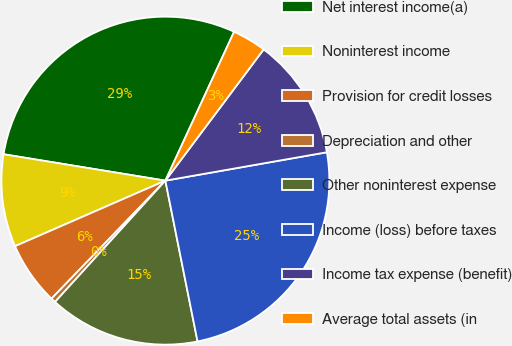Convert chart to OTSL. <chart><loc_0><loc_0><loc_500><loc_500><pie_chart><fcel>Net interest income(a)<fcel>Noninterest income<fcel>Provision for credit losses<fcel>Depreciation and other<fcel>Other noninterest expense<fcel>Income (loss) before taxes<fcel>Income tax expense (benefit)<fcel>Average total assets (in<nl><fcel>29.31%<fcel>9.12%<fcel>6.24%<fcel>0.47%<fcel>14.89%<fcel>24.63%<fcel>12.0%<fcel>3.35%<nl></chart> 